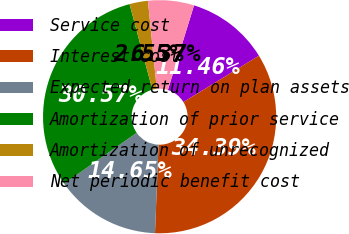<chart> <loc_0><loc_0><loc_500><loc_500><pie_chart><fcel>Service cost<fcel>Interest cost<fcel>Expected return on plan assets<fcel>Amortization of prior service<fcel>Amortization of unrecognized<fcel>Net periodic benefit cost<nl><fcel>11.46%<fcel>34.39%<fcel>14.65%<fcel>30.57%<fcel>2.55%<fcel>6.37%<nl></chart> 